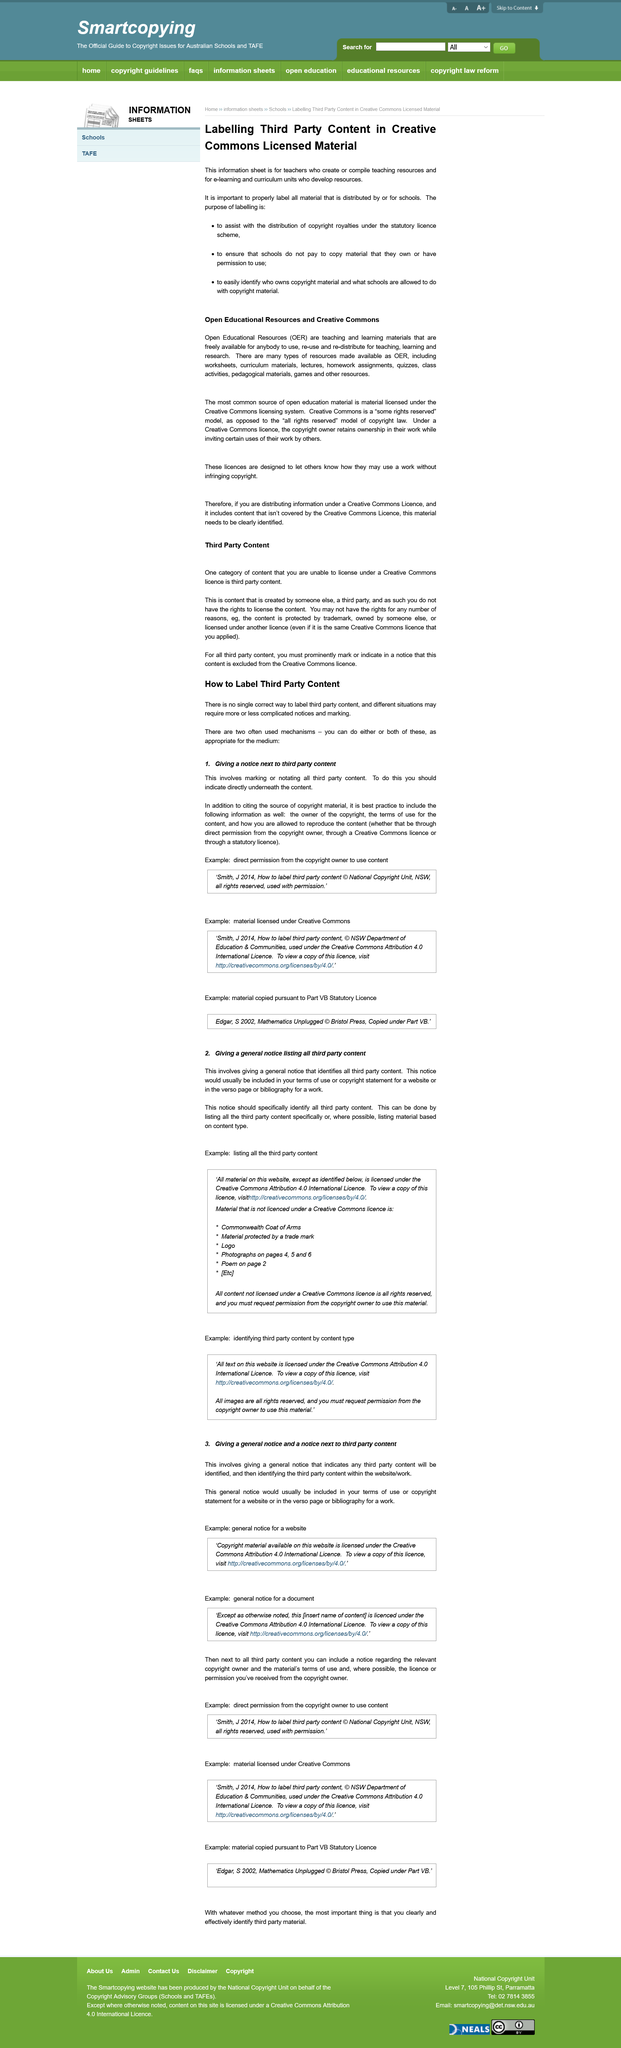Give some essential details in this illustration. Yes, different situations may require more or less complicated notices and marking. Marking or notating all third party content and providing a notice next to it is required. It is not important for schools to label material in order to ensure that they pay for material they have permission to use, but it is important for schools to label material in order to avoid paying for material they have permission to use. It is not possible to license certain types of content using a Creative Commons license, specifically third-party content. A Creative Commons license is a type of license designed to inform others on how they can use a work without infringing copyright. 